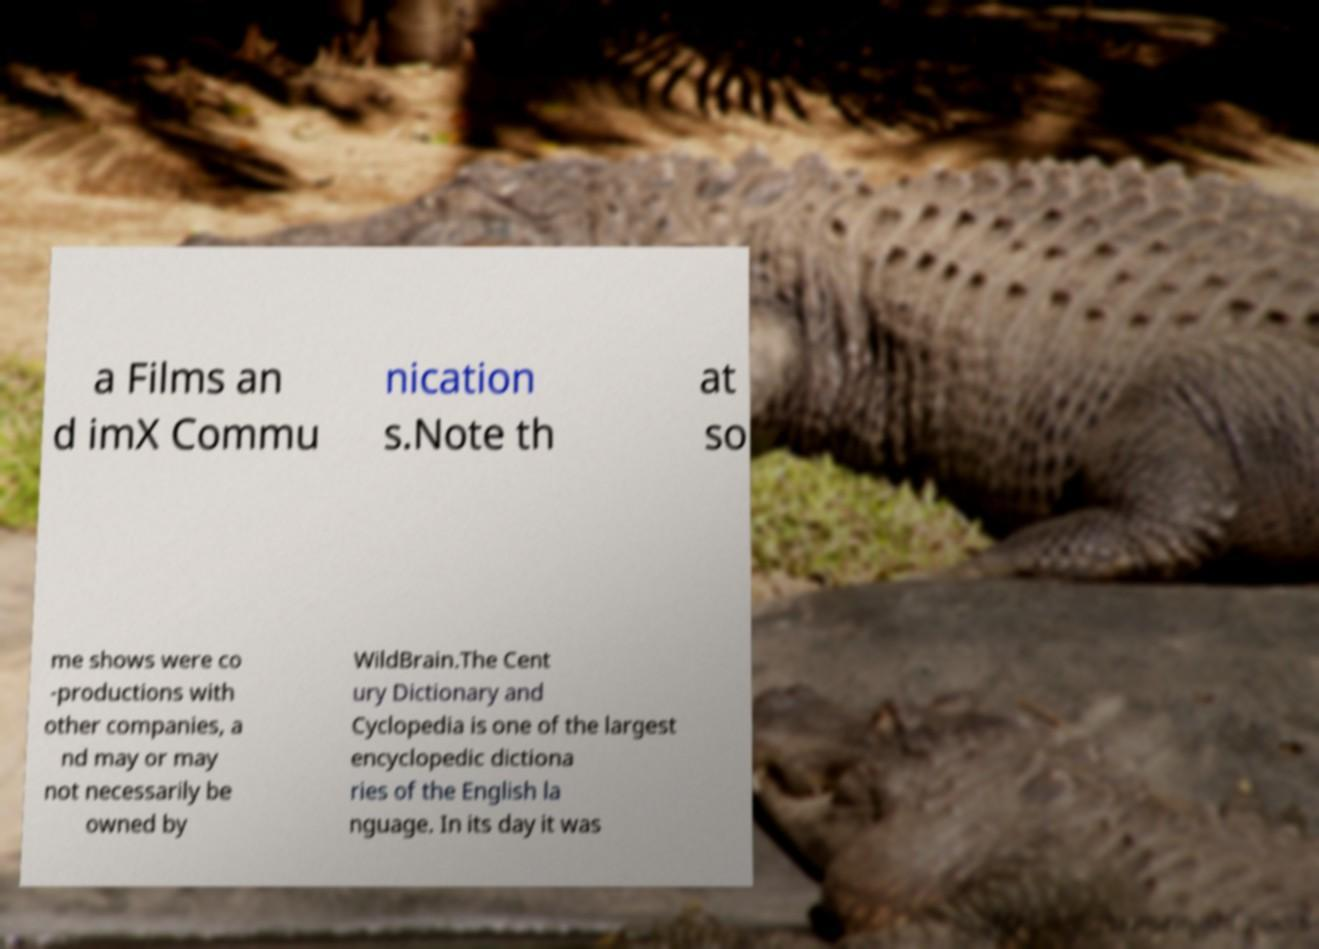For documentation purposes, I need the text within this image transcribed. Could you provide that? a Films an d imX Commu nication s.Note th at so me shows were co -productions with other companies, a nd may or may not necessarily be owned by WildBrain.The Cent ury Dictionary and Cyclopedia is one of the largest encyclopedic dictiona ries of the English la nguage. In its day it was 